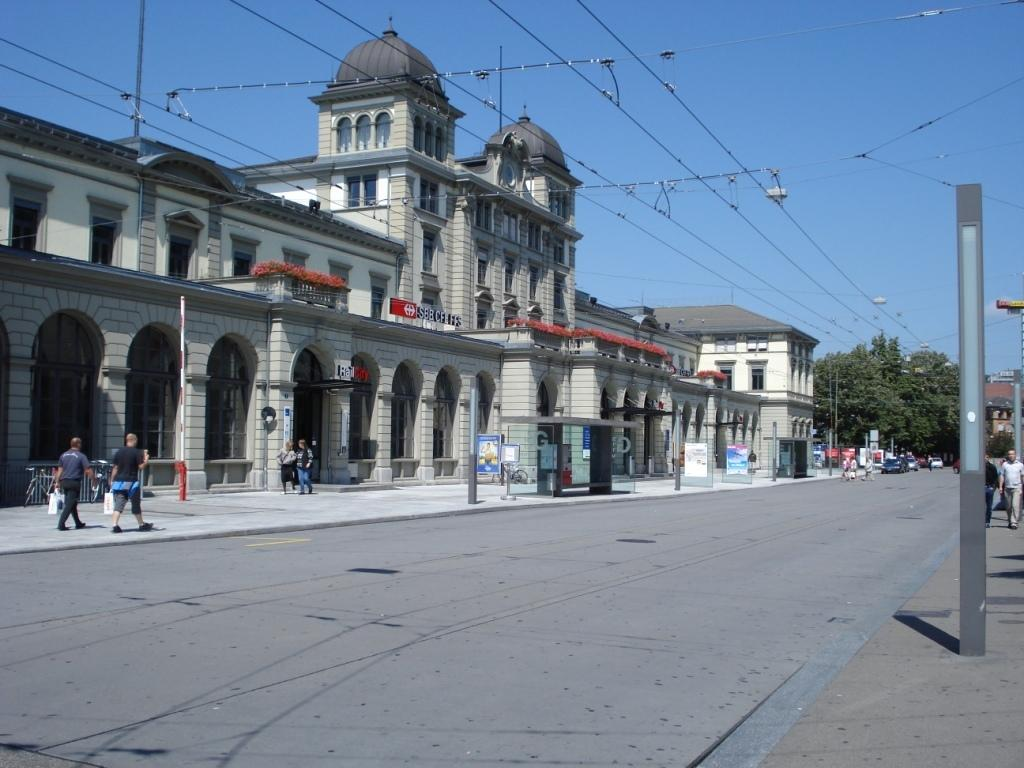What is the main feature of the image? There is a road in the image. What are the people in the image doing? There are people walking on the footpath around the road. What can be seen in the background of the image? There is a building in the background of the image, and there are trees beside the building. What type of approval is required for the chickens to cross the road in the image? There are no chickens present in the image, so no approval is needed for them to cross the road. 